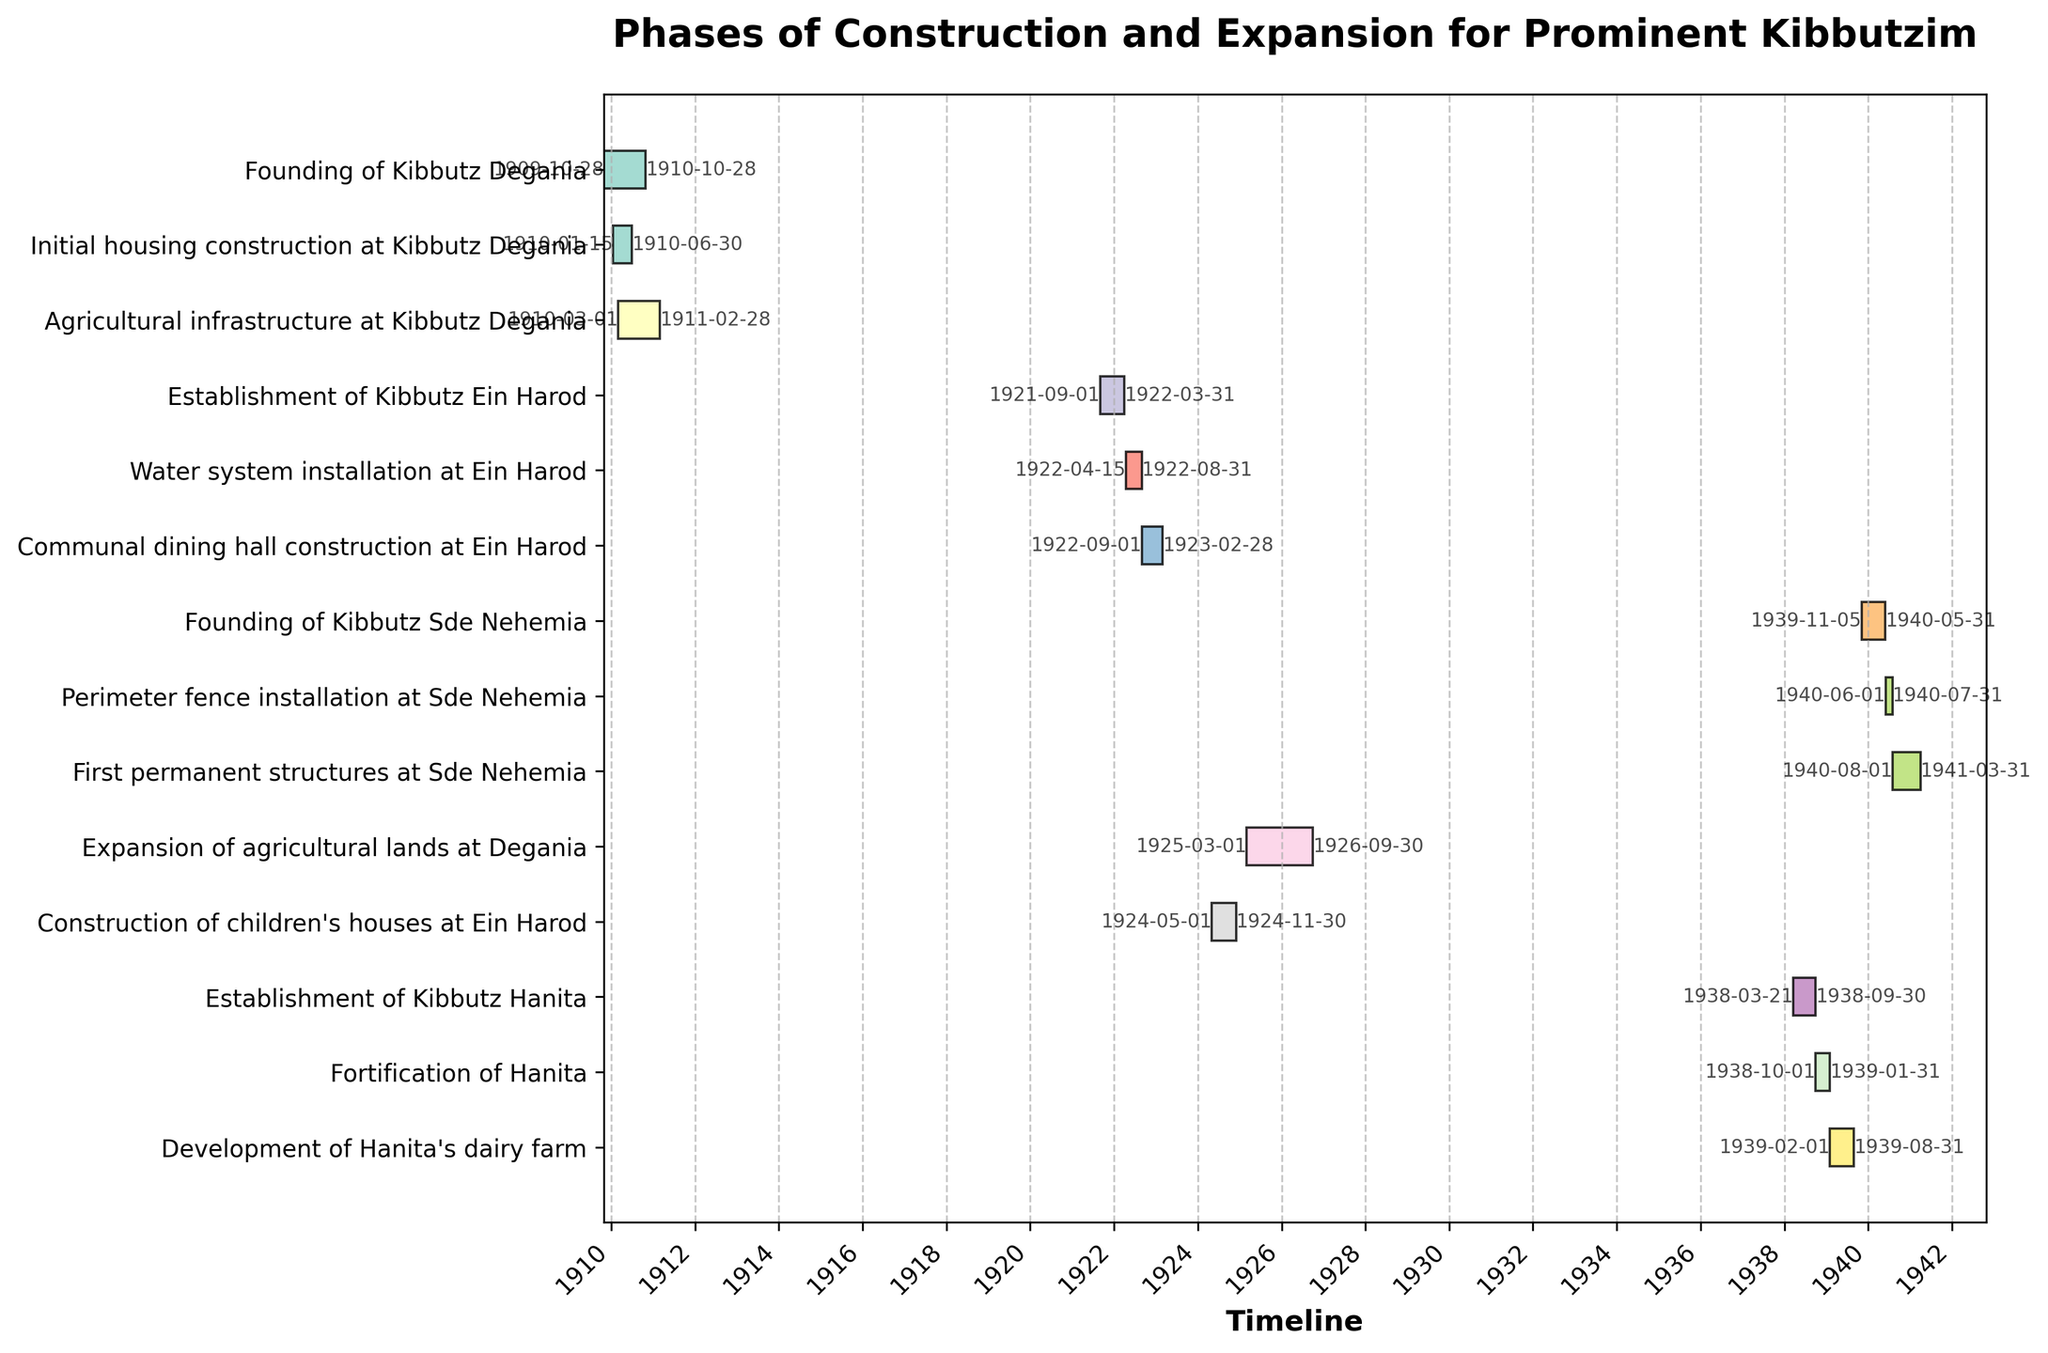How long did the initial housing construction at Kibbutz Degania take? To find the duration of the initial housing construction, we look at the start and end dates. The construction started on 1910-01-15 and ended on 1910-06-30. The duration is the difference between these two dates, which is roughly 5.5 months.
Answer: 5.5 months Which task started last? To determine which task started last, we look for the task with the most recent start date. The task "Development of Hanita's dairy farm" started on 1939-02-01, which is the latest start date among all tasks listed.
Answer: Development of Hanita's dairy farm How long did the founding process of Kibbutz Sde Nehemia take compared to the fortification of Hanita? First, find the duration of the founding of Kibbutz Sde Nehemia by calculating the difference between its start (1939-11-05) and end (1940-05-31) dates, which is approximately 6.5 months. Then, find the duration of Hanita's fortification (1938-10-01 to 1939-01-31), which is 4 months. Comparing both, the founding of Kibbutz Sde Nehemia took longer by 2.5 months.
Answer: 2.5 months Which kibbutz had the earliest infrastructure development and what was it? We need to find the earliest task related to infrastructure development by examining the start dates. The earliest infrastructure task is "Agricultural infrastructure at Kibbutz Degania," which started on 1910-03-01.
Answer: Kibbutz Degania, agricultural infrastructure How many tasks were carried out in Ein Harod and what were they? Counting the tasks involving Ein Harod and listing them: "Establishment of Kibbutz Ein Harod," "Water system installation at Ein Harod," "Communal dining hall construction at Ein Harod," and "Construction of children's houses at Ein Harod." This totals to 4 tasks.
Answer: 4 tasks: Establishment, water system installation, communal dining hall construction, children's houses construction Which task had the longest duration and what was its duration? To determine the longest task, calculate the duration for each task and find the maximum. The task "Agricultural infrastructure at Kibbutz Degania" had the longest duration from 1910-03-01 to 1911-02-28, lasting roughly 12 months.
Answer: Agricultural infrastructure at Kibbutz Degania, 12 months During which decades did the most kibbutzim-related activities happen? Identify the decades with the most tasks by grouping tasks by their start dates. Most kibbutzim-related activities happened during the 1920s and the 1930s.
Answer: 1920s and 1930s How many tasks were carried out before 1920? To count the tasks carried out before 1920, check the start dates of all tasks and count those starting before 1920. The tasks are "Founding of Kibbutz Degania," "Initial housing construction at Kibbutz Degania," and "Agricultural infrastructure at Kibbutz Degania," totaling to 3 tasks.
Answer: 3 tasks Which tasks overlapped during their timeline? Check for tasks that have overlapping dates by comparing their start and end dates. "Initial housing construction at Kibbutz Degania," "Agricultural infrastructure at Kibbutz Degania," and "Founding of Kibbutz Degania" all overlap in their timelines.
Answer: Initial housing construction and Agricultural infrastructure at Kibbutz Degania overlap with Founding of Kibbutz Degania 